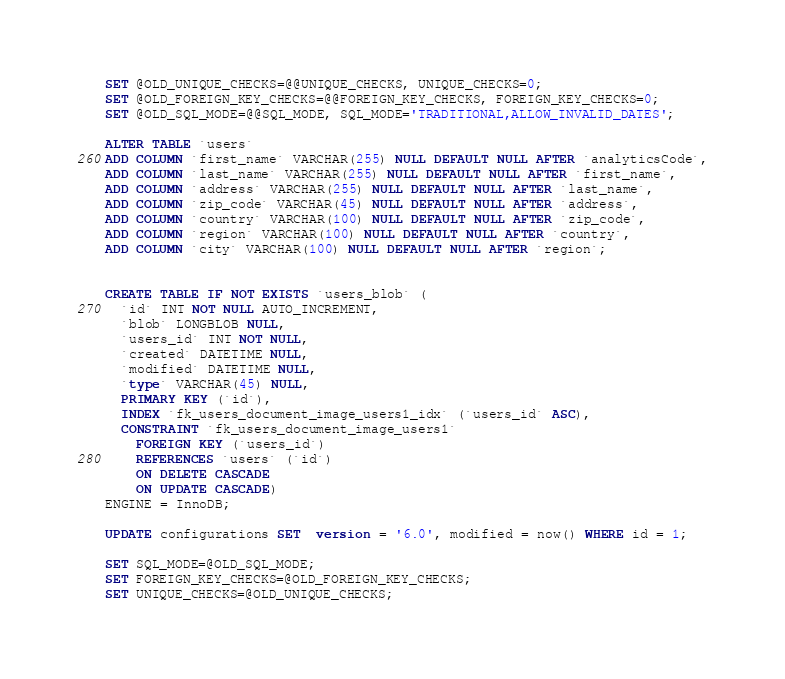Convert code to text. <code><loc_0><loc_0><loc_500><loc_500><_SQL_>SET @OLD_UNIQUE_CHECKS=@@UNIQUE_CHECKS, UNIQUE_CHECKS=0;
SET @OLD_FOREIGN_KEY_CHECKS=@@FOREIGN_KEY_CHECKS, FOREIGN_KEY_CHECKS=0;
SET @OLD_SQL_MODE=@@SQL_MODE, SQL_MODE='TRADITIONAL,ALLOW_INVALID_DATES';

ALTER TABLE `users` 
ADD COLUMN `first_name` VARCHAR(255) NULL DEFAULT NULL AFTER `analyticsCode`,
ADD COLUMN `last_name` VARCHAR(255) NULL DEFAULT NULL AFTER `first_name`,
ADD COLUMN `address` VARCHAR(255) NULL DEFAULT NULL AFTER `last_name`,
ADD COLUMN `zip_code` VARCHAR(45) NULL DEFAULT NULL AFTER `address`,
ADD COLUMN `country` VARCHAR(100) NULL DEFAULT NULL AFTER `zip_code`,
ADD COLUMN `region` VARCHAR(100) NULL DEFAULT NULL AFTER `country`,
ADD COLUMN `city` VARCHAR(100) NULL DEFAULT NULL AFTER `region`;


CREATE TABLE IF NOT EXISTS `users_blob` (
  `id` INT NOT NULL AUTO_INCREMENT,
  `blob` LONGBLOB NULL,
  `users_id` INT NOT NULL,
  `created` DATETIME NULL,
  `modified` DATETIME NULL,
  `type` VARCHAR(45) NULL,
  PRIMARY KEY (`id`),
  INDEX `fk_users_document_image_users1_idx` (`users_id` ASC),
  CONSTRAINT `fk_users_document_image_users1`
    FOREIGN KEY (`users_id`)
    REFERENCES `users` (`id`)
    ON DELETE CASCADE
    ON UPDATE CASCADE)
ENGINE = InnoDB;

UPDATE configurations SET  version = '6.0', modified = now() WHERE id = 1;

SET SQL_MODE=@OLD_SQL_MODE;
SET FOREIGN_KEY_CHECKS=@OLD_FOREIGN_KEY_CHECKS;
SET UNIQUE_CHECKS=@OLD_UNIQUE_CHECKS;
</code> 